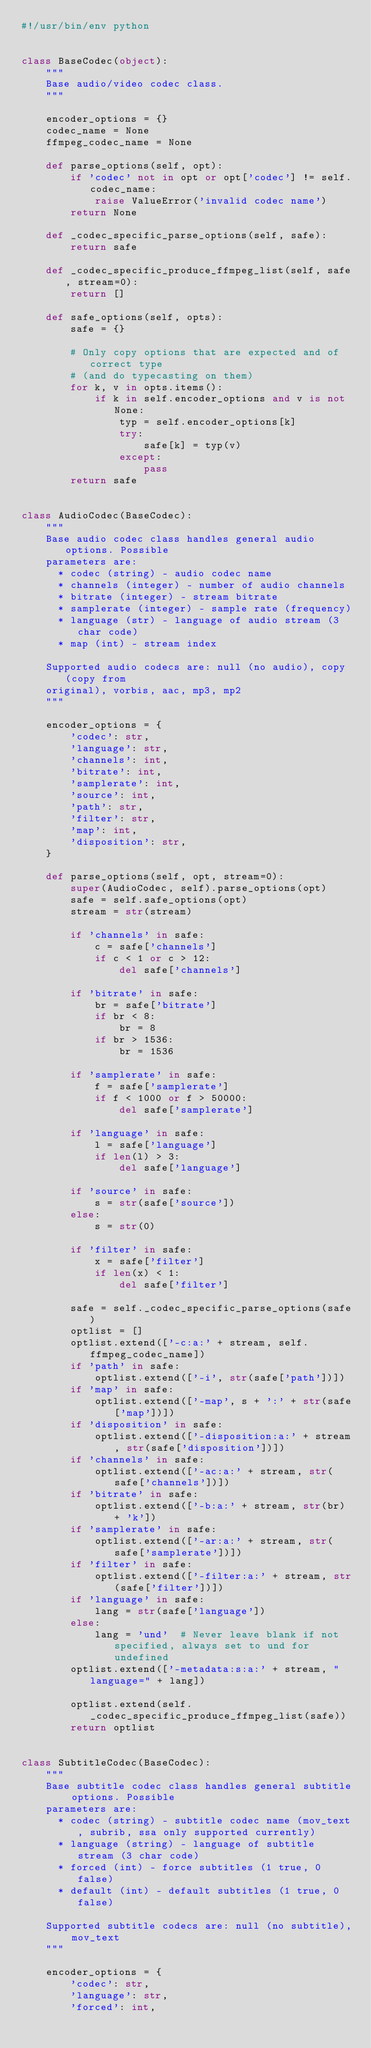<code> <loc_0><loc_0><loc_500><loc_500><_Python_>#!/usr/bin/env python


class BaseCodec(object):
    """
    Base audio/video codec class.
    """

    encoder_options = {}
    codec_name = None
    ffmpeg_codec_name = None

    def parse_options(self, opt):
        if 'codec' not in opt or opt['codec'] != self.codec_name:
            raise ValueError('invalid codec name')
        return None

    def _codec_specific_parse_options(self, safe):
        return safe

    def _codec_specific_produce_ffmpeg_list(self, safe, stream=0):
        return []

    def safe_options(self, opts):
        safe = {}

        # Only copy options that are expected and of correct type
        # (and do typecasting on them)
        for k, v in opts.items():
            if k in self.encoder_options and v is not None:
                typ = self.encoder_options[k]
                try:
                    safe[k] = typ(v)
                except:
                    pass
        return safe


class AudioCodec(BaseCodec):
    """
    Base audio codec class handles general audio options. Possible
    parameters are:
      * codec (string) - audio codec name
      * channels (integer) - number of audio channels
      * bitrate (integer) - stream bitrate
      * samplerate (integer) - sample rate (frequency)
      * language (str) - language of audio stream (3 char code)
      * map (int) - stream index

    Supported audio codecs are: null (no audio), copy (copy from
    original), vorbis, aac, mp3, mp2
    """

    encoder_options = {
        'codec': str,
        'language': str,
        'channels': int,
        'bitrate': int,
        'samplerate': int,
        'source': int,
        'path': str,
        'filter': str,
        'map': int,
        'disposition': str,
    }

    def parse_options(self, opt, stream=0):
        super(AudioCodec, self).parse_options(opt)
        safe = self.safe_options(opt)
        stream = str(stream)

        if 'channels' in safe:
            c = safe['channels']
            if c < 1 or c > 12:
                del safe['channels']

        if 'bitrate' in safe:
            br = safe['bitrate']
            if br < 8:
                br = 8
            if br > 1536:
                br = 1536

        if 'samplerate' in safe:
            f = safe['samplerate']
            if f < 1000 or f > 50000:
                del safe['samplerate']

        if 'language' in safe:
            l = safe['language']
            if len(l) > 3:
                del safe['language']

        if 'source' in safe:
            s = str(safe['source'])
        else:
            s = str(0)

        if 'filter' in safe:
            x = safe['filter']
            if len(x) < 1:
                del safe['filter']

        safe = self._codec_specific_parse_options(safe)
        optlist = []
        optlist.extend(['-c:a:' + stream, self.ffmpeg_codec_name])
        if 'path' in safe:
            optlist.extend(['-i', str(safe['path'])])
        if 'map' in safe:
            optlist.extend(['-map', s + ':' + str(safe['map'])])
        if 'disposition' in safe:
            optlist.extend(['-disposition:a:' + stream, str(safe['disposition'])])
        if 'channels' in safe:
            optlist.extend(['-ac:a:' + stream, str(safe['channels'])])
        if 'bitrate' in safe:
            optlist.extend(['-b:a:' + stream, str(br) + 'k'])
        if 'samplerate' in safe:
            optlist.extend(['-ar:a:' + stream, str(safe['samplerate'])])
        if 'filter' in safe:
            optlist.extend(['-filter:a:' + stream, str(safe['filter'])])
        if 'language' in safe:
            lang = str(safe['language'])
        else:
            lang = 'und'  # Never leave blank if not specified, always set to und for undefined
        optlist.extend(['-metadata:s:a:' + stream, "language=" + lang])

        optlist.extend(self._codec_specific_produce_ffmpeg_list(safe))
        return optlist


class SubtitleCodec(BaseCodec):
    """
    Base subtitle codec class handles general subtitle options. Possible
    parameters are:
      * codec (string) - subtitle codec name (mov_text, subrib, ssa only supported currently)
      * language (string) - language of subtitle stream (3 char code)
      * forced (int) - force subtitles (1 true, 0 false)
      * default (int) - default subtitles (1 true, 0 false)

    Supported subtitle codecs are: null (no subtitle), mov_text
    """

    encoder_options = {
        'codec': str,
        'language': str,
        'forced': int,</code> 